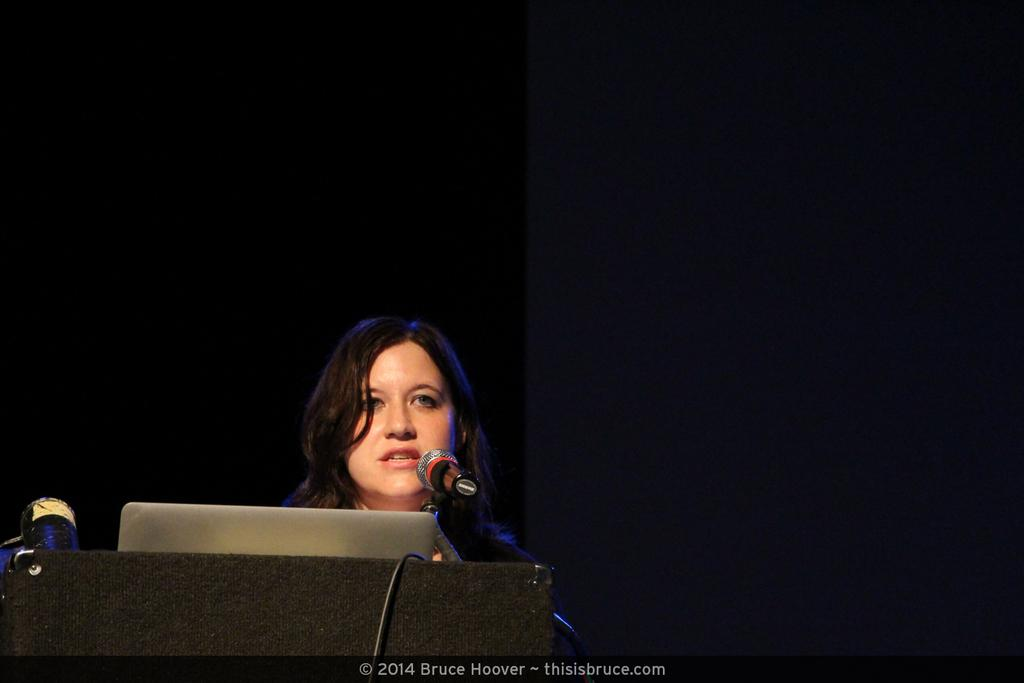What electronic device is visible in the image? There is a laptop in the image. What other object can be seen in the image related to communication or recording? There is a microphone in the image. Can you describe the person in the image? There is a woman standing in the image. How would you describe the lighting in the image? The image is dark. How many dimes are scattered on the floor in the image? There are no dimes visible in the image. What type of fuel is being used in the image? There is no reference to any fuel or energy source in the image. 